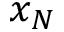Convert formula to latex. <formula><loc_0><loc_0><loc_500><loc_500>x _ { N }</formula> 